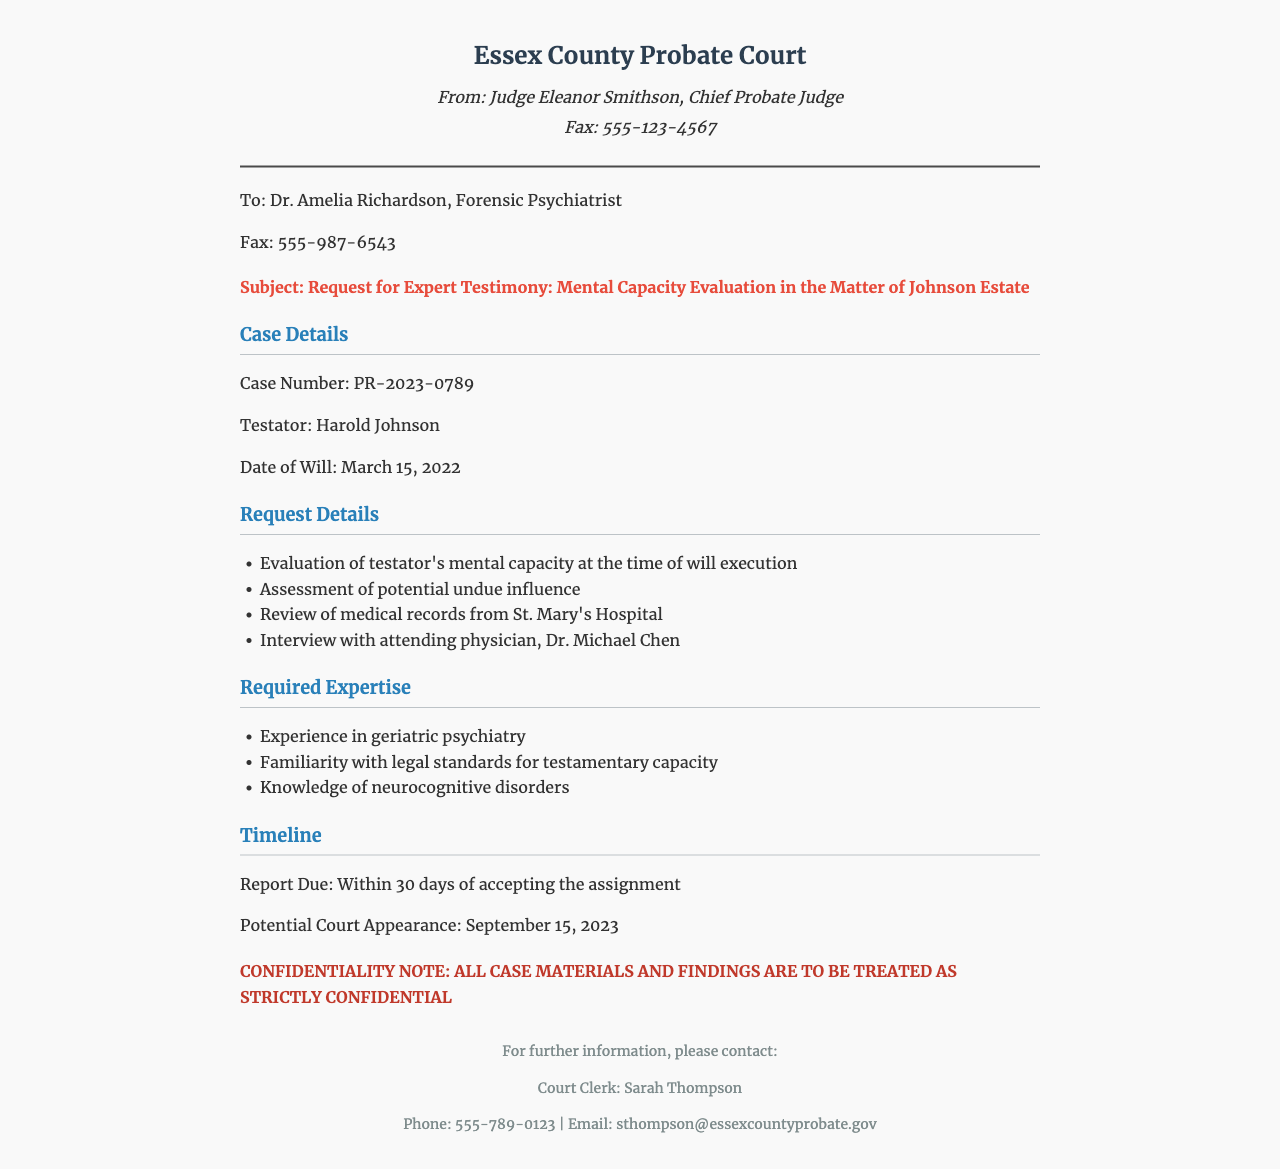What is the case number? The case number is located under the case details section of the document, specifically labeled as "Case Number."
Answer: PR-2023-0789 Who is the testator? The name of the testator is mentioned in the case details section as the individual who created the will.
Answer: Harold Johnson What is the date of the will? The date of the will is provided in the case details section clearly labeled as "Date of Will."
Answer: March 15, 2022 What is the report due date? The timeline section specifies when the report is expected to be completed by the expert.
Answer: Within 30 days of accepting the assignment What are the required expertise areas? The document outlines specific areas of knowledge that are necessary for the expert, listed in bullet points under the required expertise section.
Answer: Experience in geriatric psychiatry, Familiarity with legal standards for testamentary capacity, Knowledge of neurocognitive disorders What is the potential court appearance date? The timeline section indicates a specific date when the court appearance may happen.
Answer: September 15, 2023 Who is the court clerk? The footer section names the court clerk responsible for further information related to the case.
Answer: Sarah Thompson What is the fax number for Dr. Amelia Richardson? The recipient section lists the fax number you would use to send documents to Dr. Amelia Richardson.
Answer: 555-987-6543 What should be done with the case materials and findings? The confidentiality note clearly advises on how to handle the information related to the case materials.
Answer: Treated as strictly confidential 